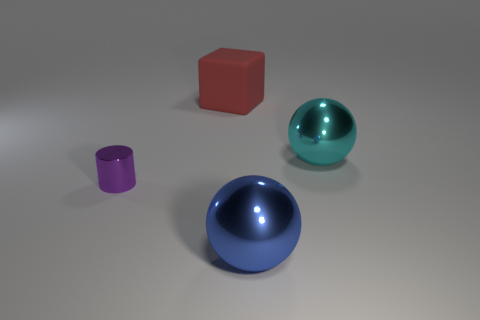Is the size of the matte thing right of the shiny cylinder the same as the small purple shiny thing?
Make the answer very short. No. What number of matte objects are either tiny blue cylinders or big cyan objects?
Your response must be concise. 0. What is the material of the thing that is in front of the red cube and on the left side of the blue thing?
Offer a terse response. Metal. Do the blue sphere and the tiny cylinder have the same material?
Offer a terse response. Yes. What size is the thing that is both in front of the big red thing and behind the cylinder?
Make the answer very short. Large. What is the shape of the blue shiny thing?
Ensure brevity in your answer.  Sphere. What number of things are either big red blocks or big metal balls behind the blue metal thing?
Ensure brevity in your answer.  2. There is a thing behind the big cyan metallic object; is its color the same as the tiny cylinder?
Offer a very short reply. No. There is a thing that is left of the blue object and in front of the rubber cube; what color is it?
Keep it short and to the point. Purple. What material is the big ball on the left side of the cyan metal object?
Provide a short and direct response. Metal. 